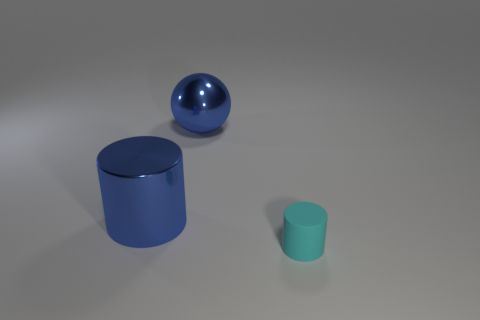Add 3 big blue shiny cylinders. How many objects exist? 6 Subtract all balls. How many objects are left? 2 Add 3 big metal spheres. How many big metal spheres are left? 4 Add 1 large yellow matte spheres. How many large yellow matte spheres exist? 1 Subtract 0 red cylinders. How many objects are left? 3 Subtract all big green cylinders. Subtract all blue objects. How many objects are left? 1 